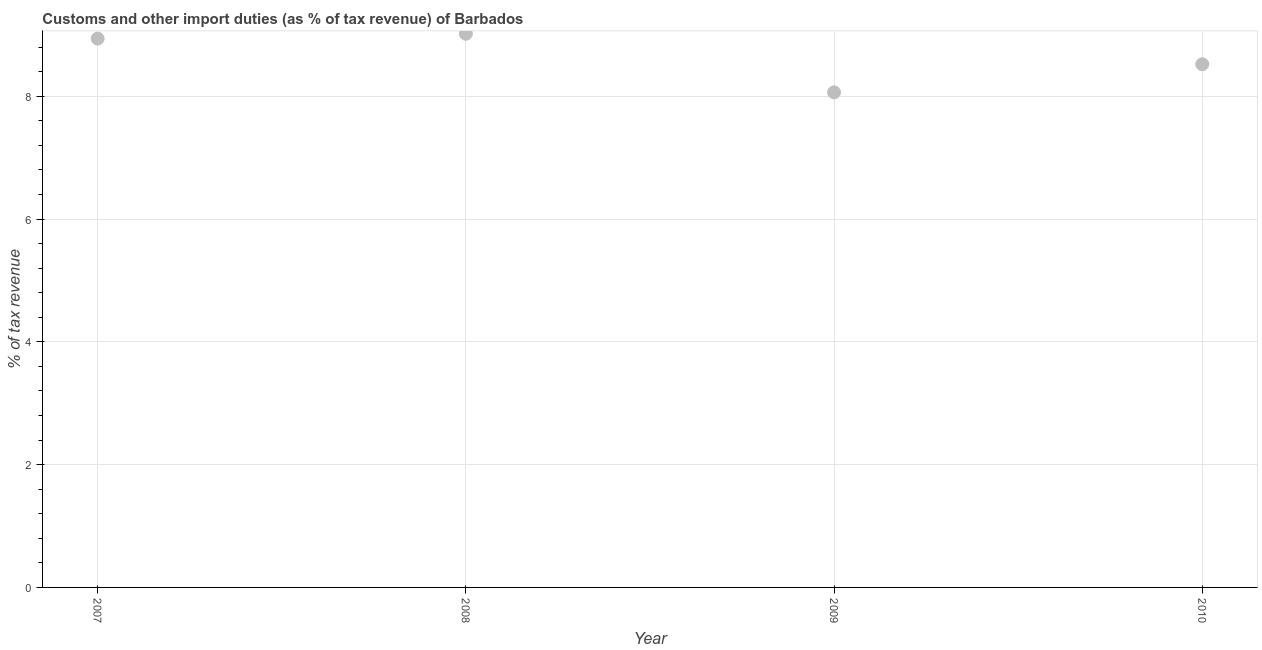What is the customs and other import duties in 2010?
Keep it short and to the point. 8.52. Across all years, what is the maximum customs and other import duties?
Your response must be concise. 9.02. Across all years, what is the minimum customs and other import duties?
Keep it short and to the point. 8.06. In which year was the customs and other import duties maximum?
Offer a very short reply. 2008. In which year was the customs and other import duties minimum?
Your response must be concise. 2009. What is the sum of the customs and other import duties?
Offer a terse response. 34.54. What is the difference between the customs and other import duties in 2008 and 2010?
Offer a very short reply. 0.5. What is the average customs and other import duties per year?
Give a very brief answer. 8.64. What is the median customs and other import duties?
Provide a short and direct response. 8.73. In how many years, is the customs and other import duties greater than 5.6 %?
Provide a short and direct response. 4. Do a majority of the years between 2009 and 2007 (inclusive) have customs and other import duties greater than 7.2 %?
Offer a terse response. No. What is the ratio of the customs and other import duties in 2008 to that in 2010?
Your answer should be very brief. 1.06. What is the difference between the highest and the second highest customs and other import duties?
Provide a succinct answer. 0.08. What is the difference between the highest and the lowest customs and other import duties?
Your answer should be very brief. 0.95. In how many years, is the customs and other import duties greater than the average customs and other import duties taken over all years?
Your answer should be compact. 2. Does the customs and other import duties monotonically increase over the years?
Make the answer very short. No. What is the difference between two consecutive major ticks on the Y-axis?
Offer a very short reply. 2. Does the graph contain any zero values?
Your answer should be very brief. No. What is the title of the graph?
Your answer should be very brief. Customs and other import duties (as % of tax revenue) of Barbados. What is the label or title of the X-axis?
Make the answer very short. Year. What is the label or title of the Y-axis?
Offer a terse response. % of tax revenue. What is the % of tax revenue in 2007?
Your answer should be compact. 8.94. What is the % of tax revenue in 2008?
Your answer should be compact. 9.02. What is the % of tax revenue in 2009?
Your response must be concise. 8.06. What is the % of tax revenue in 2010?
Keep it short and to the point. 8.52. What is the difference between the % of tax revenue in 2007 and 2008?
Your answer should be very brief. -0.08. What is the difference between the % of tax revenue in 2007 and 2009?
Provide a succinct answer. 0.88. What is the difference between the % of tax revenue in 2007 and 2010?
Your answer should be compact. 0.42. What is the difference between the % of tax revenue in 2008 and 2009?
Give a very brief answer. 0.95. What is the difference between the % of tax revenue in 2008 and 2010?
Provide a short and direct response. 0.5. What is the difference between the % of tax revenue in 2009 and 2010?
Give a very brief answer. -0.46. What is the ratio of the % of tax revenue in 2007 to that in 2009?
Offer a terse response. 1.11. What is the ratio of the % of tax revenue in 2007 to that in 2010?
Ensure brevity in your answer.  1.05. What is the ratio of the % of tax revenue in 2008 to that in 2009?
Give a very brief answer. 1.12. What is the ratio of the % of tax revenue in 2008 to that in 2010?
Offer a very short reply. 1.06. What is the ratio of the % of tax revenue in 2009 to that in 2010?
Provide a short and direct response. 0.95. 